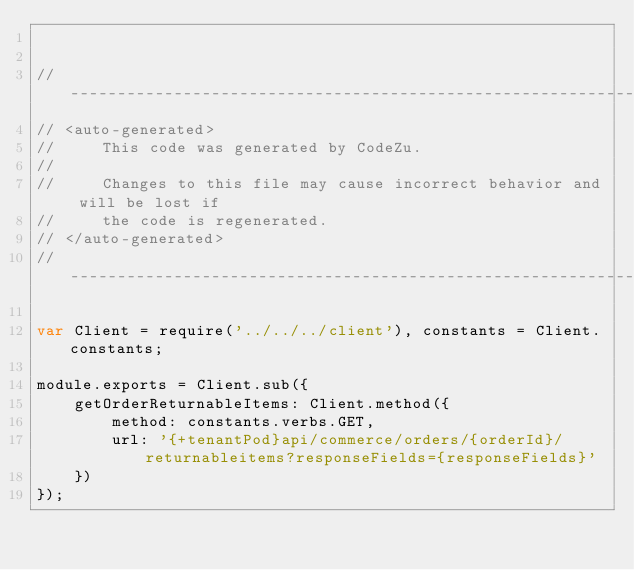Convert code to text. <code><loc_0><loc_0><loc_500><loc_500><_JavaScript_>

//------------------------------------------------------------------------------
// <auto-generated>
//     This code was generated by CodeZu.     
//
//     Changes to this file may cause incorrect behavior and will be lost if
//     the code is regenerated.
// </auto-generated>
//------------------------------------------------------------------------------

var Client = require('../../../client'), constants = Client.constants;

module.exports = Client.sub({
	getOrderReturnableItems: Client.method({
		method: constants.verbs.GET,
		url: '{+tenantPod}api/commerce/orders/{orderId}/returnableitems?responseFields={responseFields}'
	})
});
</code> 